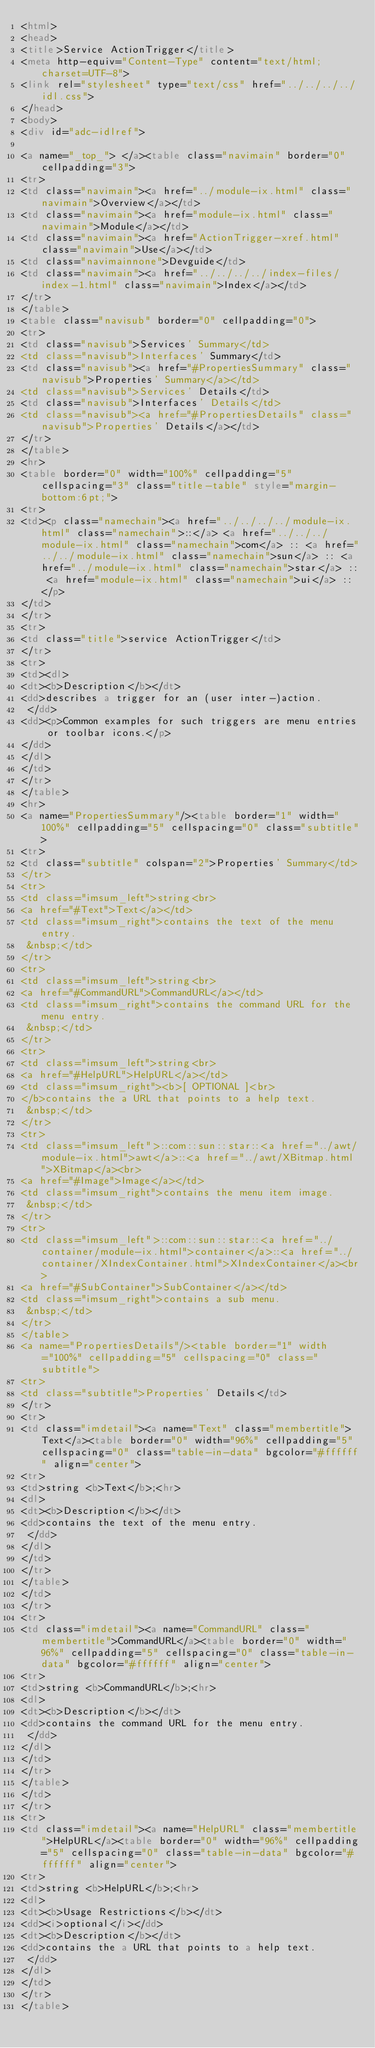<code> <loc_0><loc_0><loc_500><loc_500><_HTML_><html>
<head>
<title>Service ActionTrigger</title>
<meta http-equiv="Content-Type" content="text/html; charset=UTF-8">
<link rel="stylesheet" type="text/css" href="../../../../idl.css">
</head>
<body>
<div id="adc-idlref">

<a name="_top_"> </a><table class="navimain" border="0" cellpadding="3">
<tr>
<td class="navimain"><a href="../module-ix.html" class="navimain">Overview</a></td>
<td class="navimain"><a href="module-ix.html" class="navimain">Module</a></td>
<td class="navimain"><a href="ActionTrigger-xref.html" class="navimain">Use</a></td>
<td class="navimainnone">Devguide</td>
<td class="navimain"><a href="../../../../index-files/index-1.html" class="navimain">Index</a></td>
</tr>
</table>
<table class="navisub" border="0" cellpadding="0">
<tr>
<td class="navisub">Services' Summary</td>
<td class="navisub">Interfaces' Summary</td>
<td class="navisub"><a href="#PropertiesSummary" class="navisub">Properties' Summary</a></td>
<td class="navisub">Services' Details</td>
<td class="navisub">Interfaces' Details</td>
<td class="navisub"><a href="#PropertiesDetails" class="navisub">Properties' Details</a></td>
</tr>
</table>
<hr>
<table border="0" width="100%" cellpadding="5" cellspacing="3" class="title-table" style="margin-bottom:6pt;">
<tr>
<td><p class="namechain"><a href="../../../../module-ix.html" class="namechain">::</a> <a href="../../../module-ix.html" class="namechain">com</a> :: <a href="../../module-ix.html" class="namechain">sun</a> :: <a href="../module-ix.html" class="namechain">star</a> :: <a href="module-ix.html" class="namechain">ui</a> :: </p>
</td>
</tr>
<tr>
<td class="title">service ActionTrigger</td>
</tr>
<tr>
<td><dl>
<dt><b>Description</b></dt>
<dd>describes a trigger for an (user inter-)action.
 </dd>
<dd><p>Common examples for such triggers are menu entries or toolbar icons.</p>
</dd>
</dl>
</td>
</tr>
</table>
<hr>
<a name="PropertiesSummary"/><table border="1" width="100%" cellpadding="5" cellspacing="0" class="subtitle">
<tr>
<td class="subtitle" colspan="2">Properties' Summary</td>
</tr>
<tr>
<td class="imsum_left">string<br>
<a href="#Text">Text</a></td>
<td class="imsum_right">contains the text of the menu entry.
 &nbsp;</td>
</tr>
<tr>
<td class="imsum_left">string<br>
<a href="#CommandURL">CommandURL</a></td>
<td class="imsum_right">contains the command URL for the menu entry.
 &nbsp;</td>
</tr>
<tr>
<td class="imsum_left">string<br>
<a href="#HelpURL">HelpURL</a></td>
<td class="imsum_right"><b>[ OPTIONAL ]<br>
</b>contains the a URL that points to a help text.
 &nbsp;</td>
</tr>
<tr>
<td class="imsum_left">::com::sun::star::<a href="../awt/module-ix.html">awt</a>::<a href="../awt/XBitmap.html">XBitmap</a><br>
<a href="#Image">Image</a></td>
<td class="imsum_right">contains the menu item image.
 &nbsp;</td>
</tr>
<tr>
<td class="imsum_left">::com::sun::star::<a href="../container/module-ix.html">container</a>::<a href="../container/XIndexContainer.html">XIndexContainer</a><br>
<a href="#SubContainer">SubContainer</a></td>
<td class="imsum_right">contains a sub menu.
 &nbsp;</td>
</tr>
</table>
<a name="PropertiesDetails"/><table border="1" width="100%" cellpadding="5" cellspacing="0" class="subtitle">
<tr>
<td class="subtitle">Properties' Details</td>
</tr>
<tr>
<td class="imdetail"><a name="Text" class="membertitle">Text</a><table border="0" width="96%" cellpadding="5" cellspacing="0" class="table-in-data" bgcolor="#ffffff" align="center">
<tr>
<td>string <b>Text</b>;<hr>
<dl>
<dt><b>Description</b></dt>
<dd>contains the text of the menu entry.
 </dd>
</dl>
</td>
</tr>
</table>
</td>
</tr>
<tr>
<td class="imdetail"><a name="CommandURL" class="membertitle">CommandURL</a><table border="0" width="96%" cellpadding="5" cellspacing="0" class="table-in-data" bgcolor="#ffffff" align="center">
<tr>
<td>string <b>CommandURL</b>;<hr>
<dl>
<dt><b>Description</b></dt>
<dd>contains the command URL for the menu entry.
 </dd>
</dl>
</td>
</tr>
</table>
</td>
</tr>
<tr>
<td class="imdetail"><a name="HelpURL" class="membertitle">HelpURL</a><table border="0" width="96%" cellpadding="5" cellspacing="0" class="table-in-data" bgcolor="#ffffff" align="center">
<tr>
<td>string <b>HelpURL</b>;<hr>
<dl>
<dt><b>Usage Restrictions</b></dt>
<dd><i>optional</i></dd>
<dt><b>Description</b></dt>
<dd>contains the a URL that points to a help text.
 </dd>
</dl>
</td>
</tr>
</table></code> 